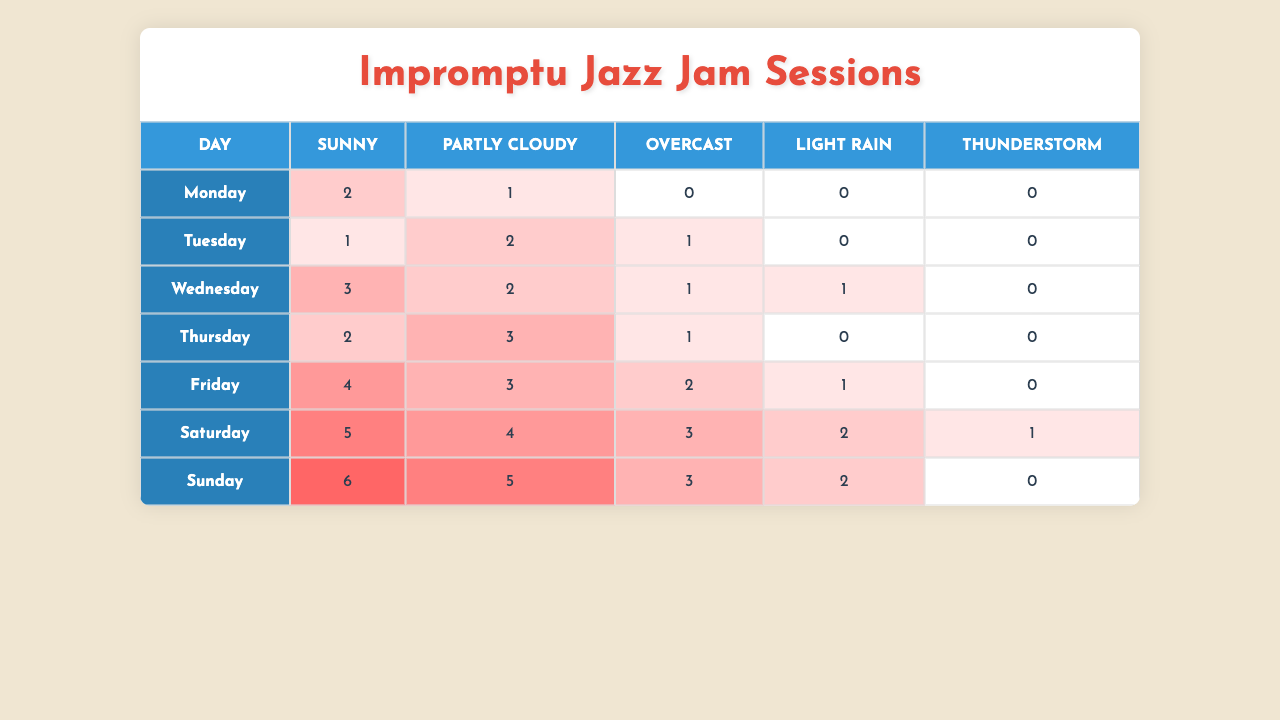What day has the highest number of jam sessions under sunny weather? Looking at the table, Saturday has 5 jam sessions under sunny conditions, which is the highest among all days.
Answer: Saturday How many jam sessions were held on Wednesday when it was partly cloudy? The table indicates that on Wednesday, there were 2 jam sessions during partly cloudy weather.
Answer: 2 Which day had the least number of jam sessions in overcast weather? From the data, Monday had 0 jam sessions when it was overcast, which is the least for that condition.
Answer: Monday What is the total number of jam sessions that took place on Fridays regardless of weather? To find the total, add the jam sessions for Friday: 4 (Sunny) + 3 (Partly Cloudy) + 2 (Overcast) + 1 (Light Rain) + 0 (Thunderstorm) = 10.
Answer: 10 On which day of the week do jam sessions occur most frequently when it thunders? Looking at the table, Thunderstorm jams occurred only on Saturday (1 session), making Saturday the day with sessions for this condition.
Answer: Saturday Did any days have an equal number of jam sessions across all weather conditions? The table shows that there are no days with equal numbers of jam sessions across all conditions; each day has varied counts.
Answer: No What is the average number of jam sessions held during sunny conditions for the weekdays? Calculate the average based on Monday, Tuesday, Wednesday, and Thursday: (2 + 1 + 3 + 2) = 8, and there are 4 weekdays, so the average is 8/4 = 2.
Answer: 2 Which weather condition has the most overall jam sessions across all days? By adding all the jam sessions for each condition, Sunny has the most (2+1+3+2+4+5+6 = 23), followed by Partly Cloudy (1+2+2+3+3+4+5 = 20).
Answer: Sunny What is the total number of jam sessions for the weekend? For Saturday and Sunday, the total is: Saturday (5+4+3+2+1=15) + Sunday (6+5+3+2+0=16) = 15 + 16 = 31.
Answer: 31 Is there a day with more than 5 jam sessions in any weather condition? Yes, Sunday has 6 jam sessions under sunny weather, which exceeds 5.
Answer: Yes 